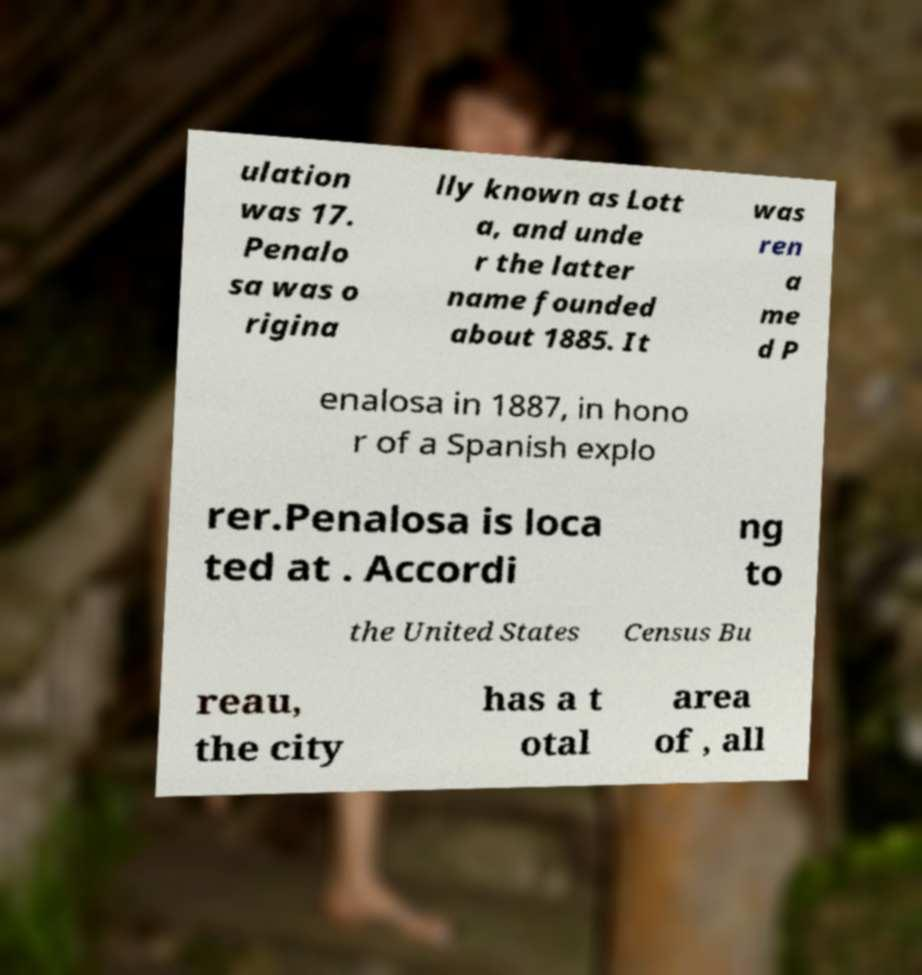For documentation purposes, I need the text within this image transcribed. Could you provide that? ulation was 17. Penalo sa was o rigina lly known as Lott a, and unde r the latter name founded about 1885. It was ren a me d P enalosa in 1887, in hono r of a Spanish explo rer.Penalosa is loca ted at . Accordi ng to the United States Census Bu reau, the city has a t otal area of , all 